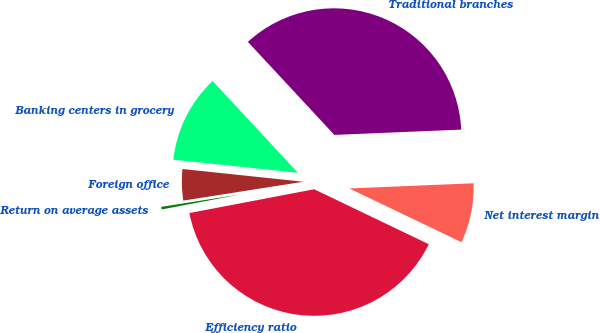Convert chart to OTSL. <chart><loc_0><loc_0><loc_500><loc_500><pie_chart><fcel>Return on average assets<fcel>Efficiency ratio<fcel>Net interest margin<fcel>Traditional branches<fcel>Banking centers in grocery<fcel>Foreign office<nl><fcel>0.52%<fcel>39.88%<fcel>7.78%<fcel>36.25%<fcel>11.41%<fcel>4.15%<nl></chart> 